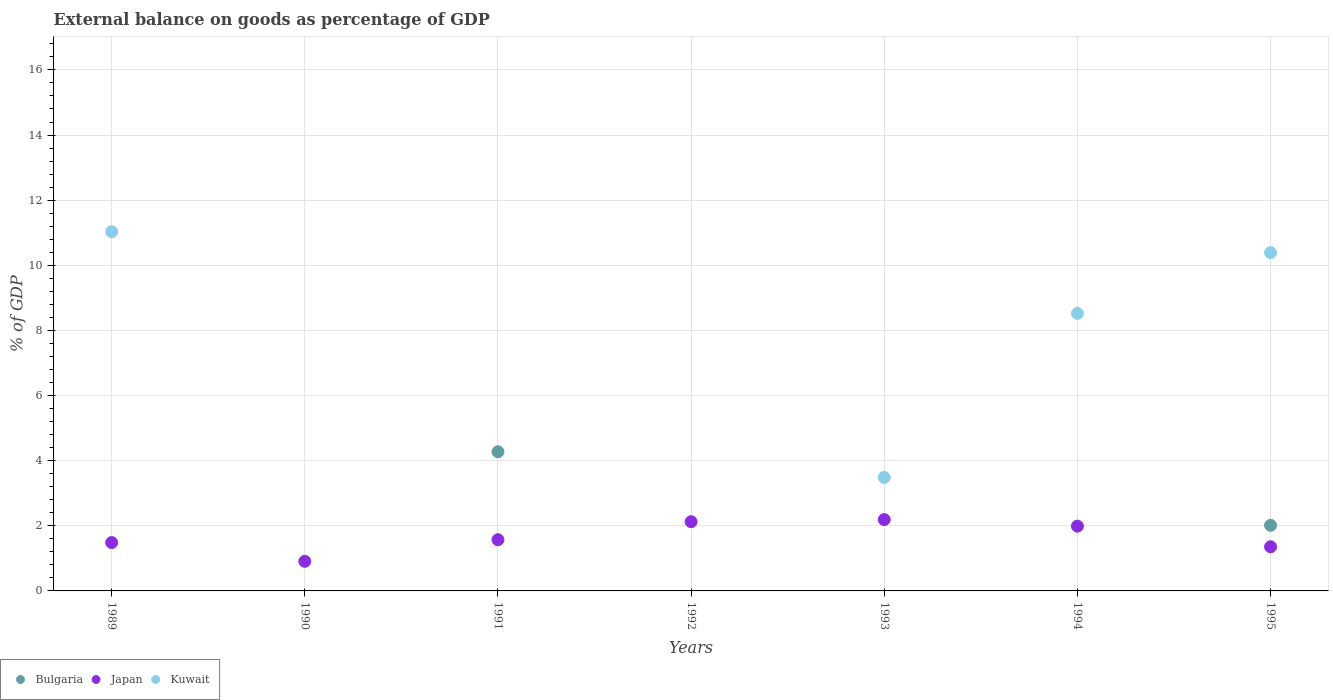How many different coloured dotlines are there?
Your answer should be very brief. 3. What is the external balance on goods as percentage of GDP in Kuwait in 1992?
Keep it short and to the point. 0. Across all years, what is the maximum external balance on goods as percentage of GDP in Bulgaria?
Keep it short and to the point. 4.27. Across all years, what is the minimum external balance on goods as percentage of GDP in Kuwait?
Ensure brevity in your answer.  0. In which year was the external balance on goods as percentage of GDP in Japan maximum?
Ensure brevity in your answer.  1993. What is the total external balance on goods as percentage of GDP in Bulgaria in the graph?
Keep it short and to the point. 6.29. What is the difference between the external balance on goods as percentage of GDP in Kuwait in 1989 and that in 1995?
Your answer should be very brief. 0.64. What is the difference between the external balance on goods as percentage of GDP in Japan in 1994 and the external balance on goods as percentage of GDP in Kuwait in 1990?
Keep it short and to the point. 1.99. What is the average external balance on goods as percentage of GDP in Japan per year?
Give a very brief answer. 1.66. In the year 1991, what is the difference between the external balance on goods as percentage of GDP in Japan and external balance on goods as percentage of GDP in Bulgaria?
Your response must be concise. -2.7. What is the ratio of the external balance on goods as percentage of GDP in Japan in 1989 to that in 1993?
Give a very brief answer. 0.68. What is the difference between the highest and the second highest external balance on goods as percentage of GDP in Japan?
Ensure brevity in your answer.  0.06. What is the difference between the highest and the lowest external balance on goods as percentage of GDP in Kuwait?
Provide a short and direct response. 11.03. In how many years, is the external balance on goods as percentage of GDP in Japan greater than the average external balance on goods as percentage of GDP in Japan taken over all years?
Keep it short and to the point. 3. Is it the case that in every year, the sum of the external balance on goods as percentage of GDP in Japan and external balance on goods as percentage of GDP in Bulgaria  is greater than the external balance on goods as percentage of GDP in Kuwait?
Provide a short and direct response. No. Does the external balance on goods as percentage of GDP in Japan monotonically increase over the years?
Keep it short and to the point. No. Is the external balance on goods as percentage of GDP in Bulgaria strictly greater than the external balance on goods as percentage of GDP in Kuwait over the years?
Give a very brief answer. No. Is the external balance on goods as percentage of GDP in Kuwait strictly less than the external balance on goods as percentage of GDP in Bulgaria over the years?
Offer a very short reply. No. How many dotlines are there?
Provide a succinct answer. 3. Are the values on the major ticks of Y-axis written in scientific E-notation?
Provide a succinct answer. No. Where does the legend appear in the graph?
Offer a terse response. Bottom left. How are the legend labels stacked?
Give a very brief answer. Horizontal. What is the title of the graph?
Ensure brevity in your answer.  External balance on goods as percentage of GDP. What is the label or title of the Y-axis?
Your answer should be compact. % of GDP. What is the % of GDP in Japan in 1989?
Your answer should be compact. 1.49. What is the % of GDP in Kuwait in 1989?
Provide a short and direct response. 11.03. What is the % of GDP of Japan in 1990?
Your response must be concise. 0.91. What is the % of GDP in Kuwait in 1990?
Keep it short and to the point. 0. What is the % of GDP of Bulgaria in 1991?
Give a very brief answer. 4.27. What is the % of GDP in Japan in 1991?
Offer a terse response. 1.57. What is the % of GDP of Kuwait in 1991?
Give a very brief answer. 0. What is the % of GDP of Japan in 1992?
Provide a short and direct response. 2.13. What is the % of GDP in Bulgaria in 1993?
Keep it short and to the point. 0. What is the % of GDP in Japan in 1993?
Ensure brevity in your answer.  2.19. What is the % of GDP of Kuwait in 1993?
Your response must be concise. 3.49. What is the % of GDP of Japan in 1994?
Offer a very short reply. 1.99. What is the % of GDP of Kuwait in 1994?
Offer a terse response. 8.52. What is the % of GDP in Bulgaria in 1995?
Provide a succinct answer. 2.01. What is the % of GDP of Japan in 1995?
Provide a short and direct response. 1.36. What is the % of GDP of Kuwait in 1995?
Your response must be concise. 10.39. Across all years, what is the maximum % of GDP of Bulgaria?
Give a very brief answer. 4.27. Across all years, what is the maximum % of GDP of Japan?
Keep it short and to the point. 2.19. Across all years, what is the maximum % of GDP in Kuwait?
Ensure brevity in your answer.  11.03. Across all years, what is the minimum % of GDP of Bulgaria?
Offer a terse response. 0. Across all years, what is the minimum % of GDP of Japan?
Give a very brief answer. 0.91. Across all years, what is the minimum % of GDP of Kuwait?
Offer a very short reply. 0. What is the total % of GDP of Bulgaria in the graph?
Offer a very short reply. 6.29. What is the total % of GDP in Japan in the graph?
Keep it short and to the point. 11.63. What is the total % of GDP in Kuwait in the graph?
Make the answer very short. 33.43. What is the difference between the % of GDP of Japan in 1989 and that in 1990?
Ensure brevity in your answer.  0.58. What is the difference between the % of GDP of Japan in 1989 and that in 1991?
Provide a succinct answer. -0.09. What is the difference between the % of GDP of Japan in 1989 and that in 1992?
Offer a very short reply. -0.64. What is the difference between the % of GDP in Japan in 1989 and that in 1993?
Offer a very short reply. -0.71. What is the difference between the % of GDP of Kuwait in 1989 and that in 1993?
Offer a very short reply. 7.55. What is the difference between the % of GDP in Japan in 1989 and that in 1994?
Your response must be concise. -0.5. What is the difference between the % of GDP of Kuwait in 1989 and that in 1994?
Your answer should be compact. 2.51. What is the difference between the % of GDP of Japan in 1989 and that in 1995?
Your answer should be very brief. 0.13. What is the difference between the % of GDP of Kuwait in 1989 and that in 1995?
Offer a terse response. 0.64. What is the difference between the % of GDP in Japan in 1990 and that in 1991?
Make the answer very short. -0.66. What is the difference between the % of GDP of Japan in 1990 and that in 1992?
Offer a terse response. -1.22. What is the difference between the % of GDP in Japan in 1990 and that in 1993?
Provide a succinct answer. -1.28. What is the difference between the % of GDP of Japan in 1990 and that in 1994?
Your response must be concise. -1.08. What is the difference between the % of GDP of Japan in 1990 and that in 1995?
Offer a very short reply. -0.45. What is the difference between the % of GDP of Japan in 1991 and that in 1992?
Your response must be concise. -0.55. What is the difference between the % of GDP of Japan in 1991 and that in 1993?
Provide a succinct answer. -0.62. What is the difference between the % of GDP of Japan in 1991 and that in 1994?
Offer a very short reply. -0.42. What is the difference between the % of GDP in Bulgaria in 1991 and that in 1995?
Your answer should be very brief. 2.26. What is the difference between the % of GDP of Japan in 1991 and that in 1995?
Offer a very short reply. 0.22. What is the difference between the % of GDP of Japan in 1992 and that in 1993?
Make the answer very short. -0.06. What is the difference between the % of GDP in Japan in 1992 and that in 1994?
Offer a terse response. 0.14. What is the difference between the % of GDP in Japan in 1992 and that in 1995?
Keep it short and to the point. 0.77. What is the difference between the % of GDP of Japan in 1993 and that in 1994?
Keep it short and to the point. 0.2. What is the difference between the % of GDP of Kuwait in 1993 and that in 1994?
Provide a short and direct response. -5.04. What is the difference between the % of GDP in Japan in 1993 and that in 1995?
Give a very brief answer. 0.84. What is the difference between the % of GDP in Kuwait in 1993 and that in 1995?
Your answer should be compact. -6.9. What is the difference between the % of GDP in Japan in 1994 and that in 1995?
Your response must be concise. 0.63. What is the difference between the % of GDP in Kuwait in 1994 and that in 1995?
Give a very brief answer. -1.87. What is the difference between the % of GDP of Japan in 1989 and the % of GDP of Kuwait in 1993?
Give a very brief answer. -2. What is the difference between the % of GDP of Japan in 1989 and the % of GDP of Kuwait in 1994?
Your answer should be very brief. -7.04. What is the difference between the % of GDP of Japan in 1989 and the % of GDP of Kuwait in 1995?
Ensure brevity in your answer.  -8.9. What is the difference between the % of GDP of Japan in 1990 and the % of GDP of Kuwait in 1993?
Your response must be concise. -2.58. What is the difference between the % of GDP in Japan in 1990 and the % of GDP in Kuwait in 1994?
Give a very brief answer. -7.61. What is the difference between the % of GDP in Japan in 1990 and the % of GDP in Kuwait in 1995?
Make the answer very short. -9.48. What is the difference between the % of GDP in Bulgaria in 1991 and the % of GDP in Japan in 1992?
Give a very brief answer. 2.15. What is the difference between the % of GDP of Bulgaria in 1991 and the % of GDP of Japan in 1993?
Keep it short and to the point. 2.08. What is the difference between the % of GDP in Bulgaria in 1991 and the % of GDP in Kuwait in 1993?
Provide a succinct answer. 0.79. What is the difference between the % of GDP in Japan in 1991 and the % of GDP in Kuwait in 1993?
Make the answer very short. -1.91. What is the difference between the % of GDP of Bulgaria in 1991 and the % of GDP of Japan in 1994?
Offer a terse response. 2.28. What is the difference between the % of GDP in Bulgaria in 1991 and the % of GDP in Kuwait in 1994?
Your answer should be compact. -4.25. What is the difference between the % of GDP of Japan in 1991 and the % of GDP of Kuwait in 1994?
Provide a short and direct response. -6.95. What is the difference between the % of GDP in Bulgaria in 1991 and the % of GDP in Japan in 1995?
Keep it short and to the point. 2.92. What is the difference between the % of GDP of Bulgaria in 1991 and the % of GDP of Kuwait in 1995?
Your answer should be very brief. -6.12. What is the difference between the % of GDP of Japan in 1991 and the % of GDP of Kuwait in 1995?
Offer a very short reply. -8.82. What is the difference between the % of GDP of Japan in 1992 and the % of GDP of Kuwait in 1993?
Provide a succinct answer. -1.36. What is the difference between the % of GDP of Japan in 1992 and the % of GDP of Kuwait in 1994?
Keep it short and to the point. -6.4. What is the difference between the % of GDP in Japan in 1992 and the % of GDP in Kuwait in 1995?
Provide a short and direct response. -8.26. What is the difference between the % of GDP of Japan in 1993 and the % of GDP of Kuwait in 1994?
Offer a very short reply. -6.33. What is the difference between the % of GDP of Japan in 1993 and the % of GDP of Kuwait in 1995?
Provide a succinct answer. -8.2. What is the difference between the % of GDP in Japan in 1994 and the % of GDP in Kuwait in 1995?
Give a very brief answer. -8.4. What is the average % of GDP of Bulgaria per year?
Provide a succinct answer. 0.9. What is the average % of GDP of Japan per year?
Give a very brief answer. 1.66. What is the average % of GDP in Kuwait per year?
Your answer should be very brief. 4.78. In the year 1989, what is the difference between the % of GDP of Japan and % of GDP of Kuwait?
Offer a terse response. -9.55. In the year 1991, what is the difference between the % of GDP of Bulgaria and % of GDP of Japan?
Offer a very short reply. 2.7. In the year 1993, what is the difference between the % of GDP in Japan and % of GDP in Kuwait?
Your answer should be very brief. -1.29. In the year 1994, what is the difference between the % of GDP of Japan and % of GDP of Kuwait?
Make the answer very short. -6.53. In the year 1995, what is the difference between the % of GDP in Bulgaria and % of GDP in Japan?
Ensure brevity in your answer.  0.66. In the year 1995, what is the difference between the % of GDP of Bulgaria and % of GDP of Kuwait?
Offer a terse response. -8.37. In the year 1995, what is the difference between the % of GDP in Japan and % of GDP in Kuwait?
Make the answer very short. -9.03. What is the ratio of the % of GDP in Japan in 1989 to that in 1990?
Keep it short and to the point. 1.63. What is the ratio of the % of GDP in Japan in 1989 to that in 1991?
Your answer should be very brief. 0.94. What is the ratio of the % of GDP of Japan in 1989 to that in 1992?
Provide a succinct answer. 0.7. What is the ratio of the % of GDP of Japan in 1989 to that in 1993?
Make the answer very short. 0.68. What is the ratio of the % of GDP of Kuwait in 1989 to that in 1993?
Give a very brief answer. 3.17. What is the ratio of the % of GDP in Japan in 1989 to that in 1994?
Your response must be concise. 0.75. What is the ratio of the % of GDP of Kuwait in 1989 to that in 1994?
Offer a terse response. 1.29. What is the ratio of the % of GDP in Japan in 1989 to that in 1995?
Give a very brief answer. 1.1. What is the ratio of the % of GDP of Kuwait in 1989 to that in 1995?
Your response must be concise. 1.06. What is the ratio of the % of GDP in Japan in 1990 to that in 1991?
Your response must be concise. 0.58. What is the ratio of the % of GDP of Japan in 1990 to that in 1992?
Provide a succinct answer. 0.43. What is the ratio of the % of GDP in Japan in 1990 to that in 1993?
Offer a very short reply. 0.41. What is the ratio of the % of GDP in Japan in 1990 to that in 1994?
Give a very brief answer. 0.46. What is the ratio of the % of GDP in Japan in 1990 to that in 1995?
Provide a short and direct response. 0.67. What is the ratio of the % of GDP in Japan in 1991 to that in 1992?
Provide a succinct answer. 0.74. What is the ratio of the % of GDP of Japan in 1991 to that in 1993?
Offer a terse response. 0.72. What is the ratio of the % of GDP in Japan in 1991 to that in 1994?
Provide a succinct answer. 0.79. What is the ratio of the % of GDP of Bulgaria in 1991 to that in 1995?
Your answer should be compact. 2.12. What is the ratio of the % of GDP of Japan in 1991 to that in 1995?
Your answer should be compact. 1.16. What is the ratio of the % of GDP in Japan in 1992 to that in 1993?
Offer a terse response. 0.97. What is the ratio of the % of GDP of Japan in 1992 to that in 1994?
Your response must be concise. 1.07. What is the ratio of the % of GDP in Japan in 1992 to that in 1995?
Keep it short and to the point. 1.57. What is the ratio of the % of GDP of Japan in 1993 to that in 1994?
Keep it short and to the point. 1.1. What is the ratio of the % of GDP of Kuwait in 1993 to that in 1994?
Keep it short and to the point. 0.41. What is the ratio of the % of GDP of Japan in 1993 to that in 1995?
Give a very brief answer. 1.62. What is the ratio of the % of GDP in Kuwait in 1993 to that in 1995?
Make the answer very short. 0.34. What is the ratio of the % of GDP of Japan in 1994 to that in 1995?
Keep it short and to the point. 1.47. What is the ratio of the % of GDP in Kuwait in 1994 to that in 1995?
Give a very brief answer. 0.82. What is the difference between the highest and the second highest % of GDP of Japan?
Offer a very short reply. 0.06. What is the difference between the highest and the second highest % of GDP of Kuwait?
Keep it short and to the point. 0.64. What is the difference between the highest and the lowest % of GDP in Bulgaria?
Your answer should be very brief. 4.27. What is the difference between the highest and the lowest % of GDP in Japan?
Provide a succinct answer. 1.28. What is the difference between the highest and the lowest % of GDP in Kuwait?
Ensure brevity in your answer.  11.03. 